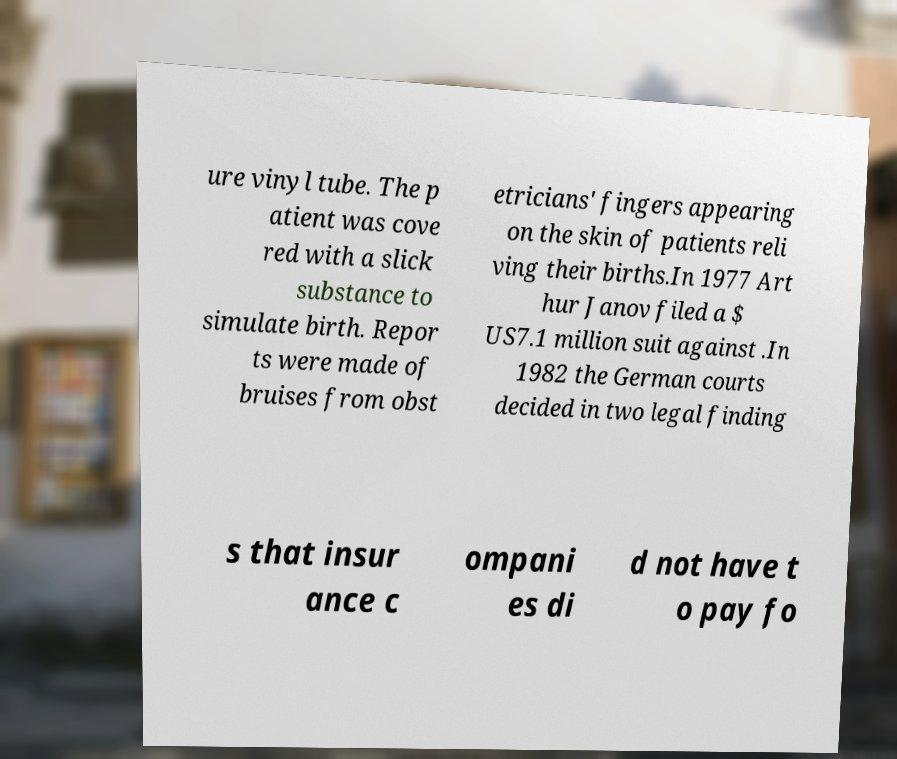Could you extract and type out the text from this image? ure vinyl tube. The p atient was cove red with a slick substance to simulate birth. Repor ts were made of bruises from obst etricians' fingers appearing on the skin of patients reli ving their births.In 1977 Art hur Janov filed a $ US7.1 million suit against .In 1982 the German courts decided in two legal finding s that insur ance c ompani es di d not have t o pay fo 